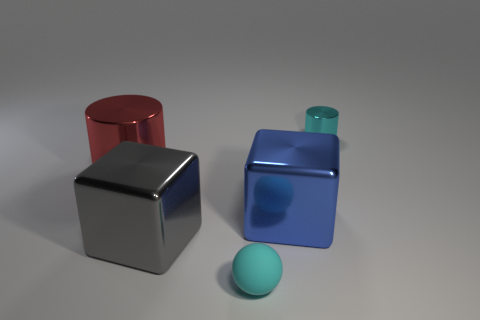Is there a cyan matte object that has the same size as the blue object?
Make the answer very short. No. Is the color of the block that is right of the big gray metallic block the same as the big cube that is left of the blue metal cube?
Ensure brevity in your answer.  No. Is there a big shiny object that has the same color as the rubber thing?
Your answer should be very brief. No. What number of other objects are there of the same shape as the gray shiny object?
Provide a succinct answer. 1. There is a small cyan thing in front of the large red metallic thing; what shape is it?
Provide a short and direct response. Sphere. Is the shape of the rubber thing the same as the large metallic thing right of the tiny matte sphere?
Make the answer very short. No. What size is the metallic object that is in front of the red cylinder and on the left side of the cyan rubber object?
Provide a succinct answer. Large. There is a large metal object that is to the left of the small ball and in front of the large cylinder; what color is it?
Ensure brevity in your answer.  Gray. Is there any other thing that has the same material as the small cyan cylinder?
Keep it short and to the point. Yes. Is the number of cyan matte balls that are left of the big red metallic thing less than the number of things that are behind the gray thing?
Your answer should be compact. Yes. 